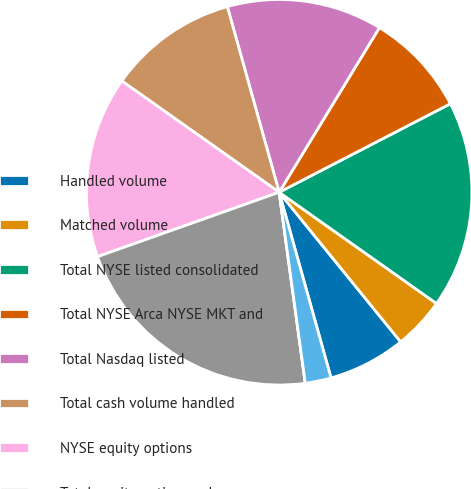Convert chart. <chart><loc_0><loc_0><loc_500><loc_500><pie_chart><fcel>Handled volume<fcel>Matched volume<fcel>Total NYSE listed consolidated<fcel>Total NYSE Arca NYSE MKT and<fcel>Total Nasdaq listed<fcel>Total cash volume handled<fcel>NYSE equity options<fcel>Total equity options volume<fcel>Cash products revenue capture<fcel>Equity options rate per<nl><fcel>6.52%<fcel>4.35%<fcel>17.39%<fcel>8.7%<fcel>13.04%<fcel>10.87%<fcel>15.22%<fcel>21.74%<fcel>0.0%<fcel>2.17%<nl></chart> 